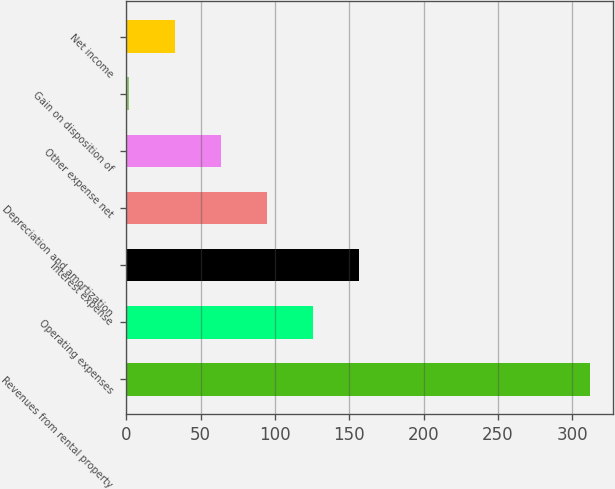<chart> <loc_0><loc_0><loc_500><loc_500><bar_chart><fcel>Revenues from rental property<fcel>Operating expenses<fcel>Interest expense<fcel>Depreciation and amortization<fcel>Other expense net<fcel>Gain on disposition of<fcel>Net income<nl><fcel>311.9<fcel>125.78<fcel>156.8<fcel>94.76<fcel>63.74<fcel>1.7<fcel>32.72<nl></chart> 